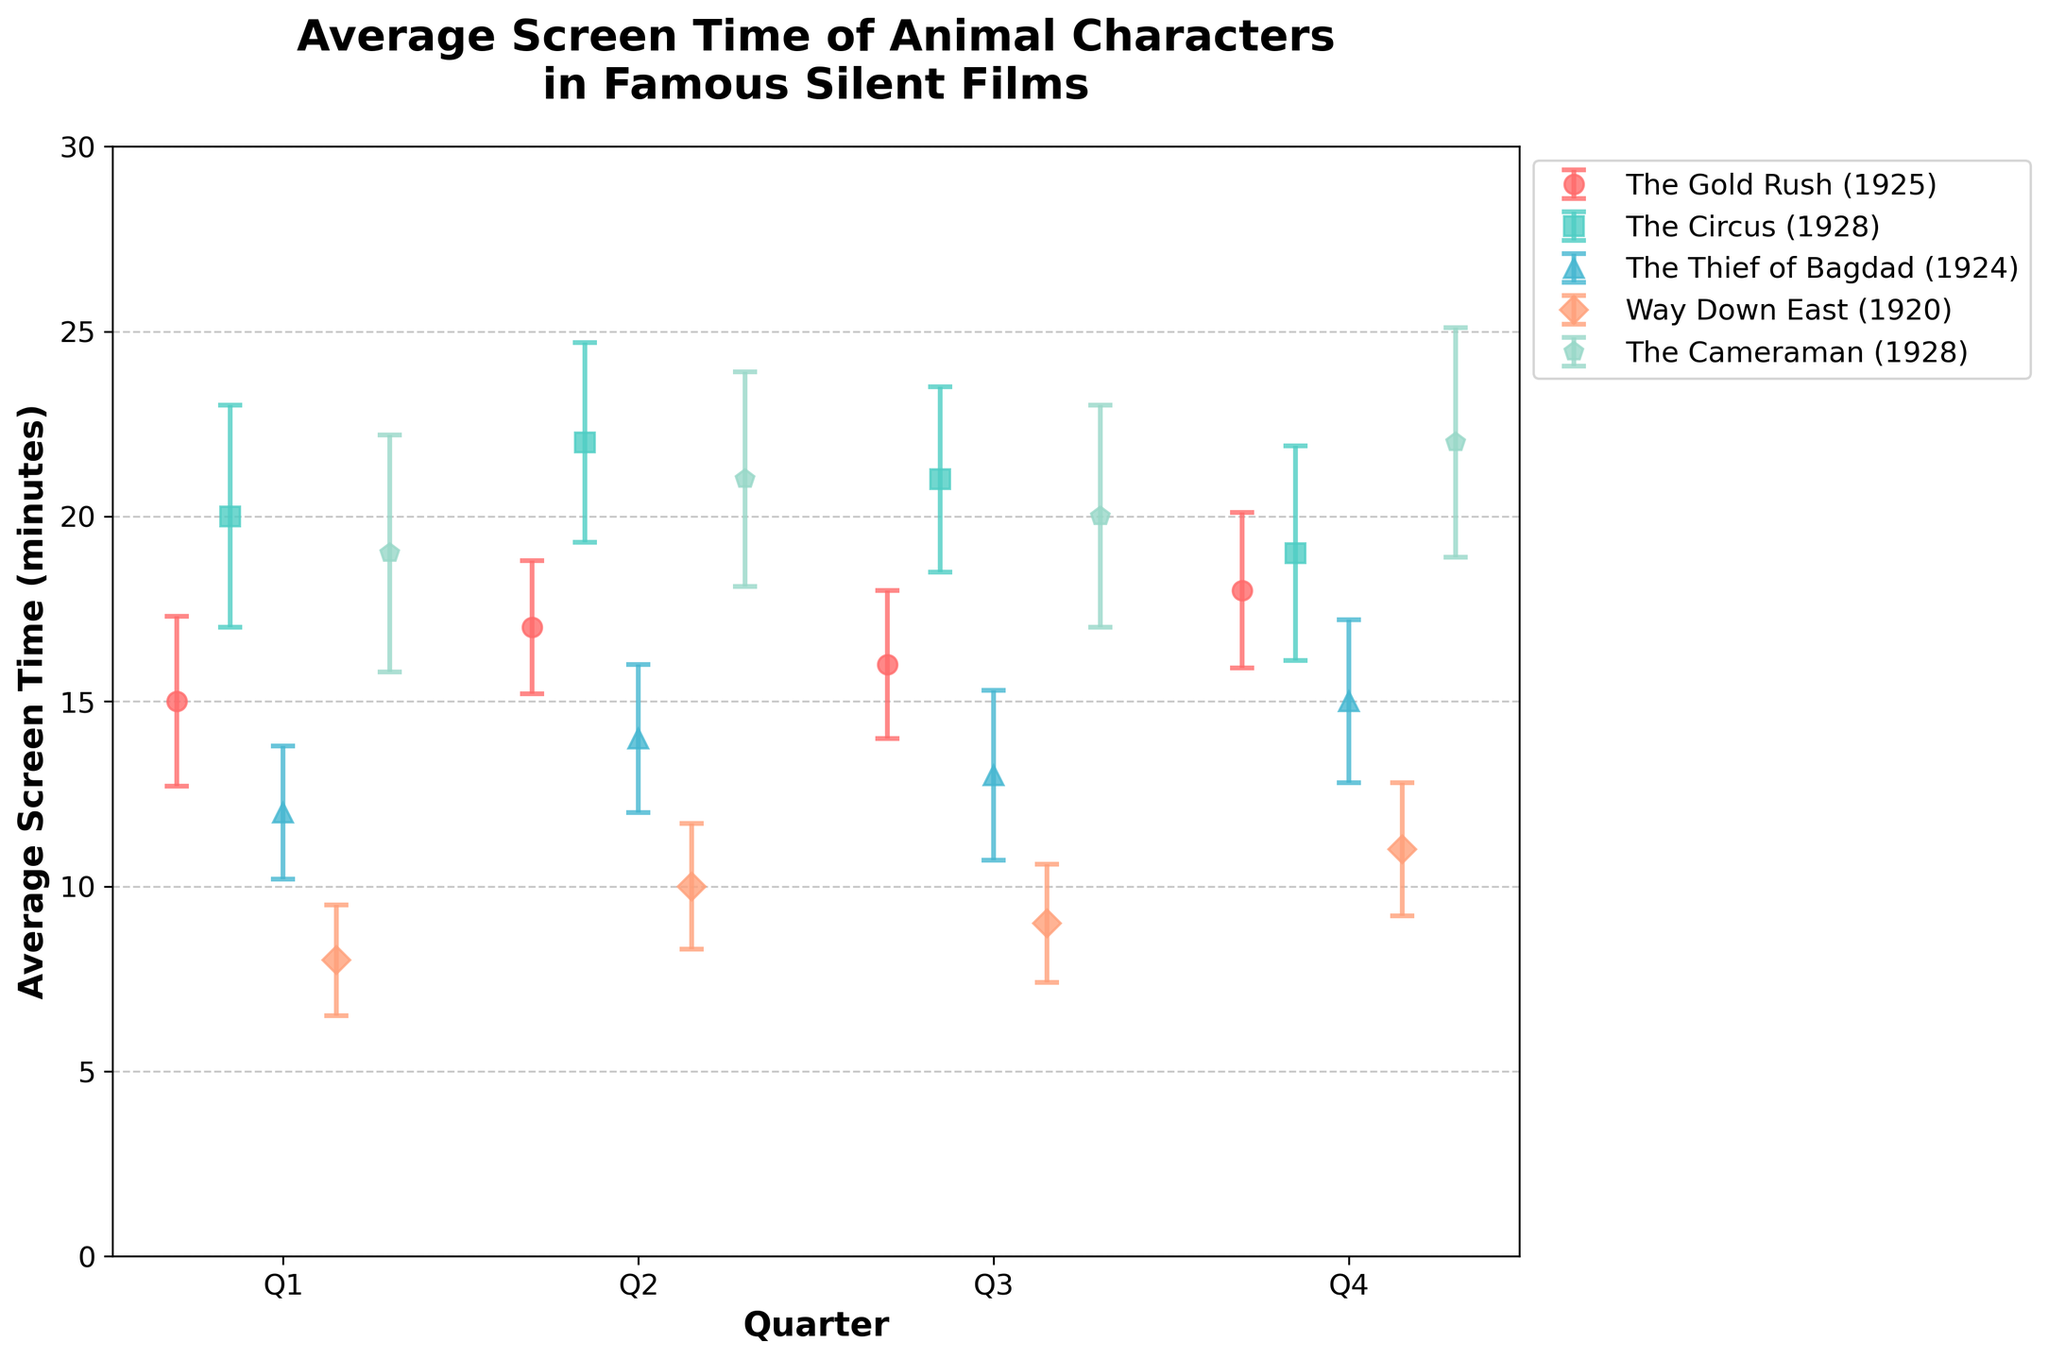What's the title of the figure? The titles of figures are typically found at the top and they are meant to describe the content of the figure concisely. The title of this figure is "Average Screen Time of Animal Characters in Famous Silent Films" along with a subtitle indicating quarterly variations.
Answer: Average Screen Time of Animal Characters in Famous Silent Films Which film has the highest average screen time for Q1? To find the film with the highest average screen time for Q1, locate the markers on the plot that correspond to Q1 and identify the one with the greatest height. "The Circus (1928)" has the highest marker in Q1.
Answer: "The Circus (1928)" What is the average screen time and the standard deviation for "The Thief of Bagdad (1924)" in Q3? Find the data points for "The Thief of Bagdad (1924)" and look specifically at Q3. The marker tells us the average screen time and the error bars indicate the standard deviation. The average is 13 minutes and the standard deviation is 2.3 minutes.
Answer: 13 minutes, 2.3 minutes Which quarter shows the greatest variation in screen time for "Way Down East (1920)"? To determine the quarter with the greatest variation, compare the lengths of the error bars (standard deviations) for each quarter in "Way Down East (1920)". Quarter 4 (Q4) has the longest error bar.
Answer: Q4 How does the average screen time of animal characters in "The Cameraman (1928)" change from Q1 to Q4? Track the changes in the vertical positions of the error bars for "The Cameraman (1928)" from Q1 to Q4. The average screen time increases from Q1 to Q4 (19 to 22 minutes).
Answer: Increases Which film has the smallest variability in screen time in Q2? To find out which film has the smallest variability, compare the lengths of the error bars (standard deviations) for Q2. "The Gold Rush (1925)" has the shortest error bar in Q2 with a standard deviation of 1.8 minutes.
Answer: "The Gold Rush (1925)" What is the difference in average screen time between Q4 and Q1 for "The Gold Rush (1925)"? Calculate the difference between the average screen times for Q4 and Q1 for "The Gold Rush (1925)". For Q4, the average screen time is 18 minutes and for Q1, it is 15 minutes. The difference is 18 - 15 = 3 minutes.
Answer: 3 minutes Which film shows a decrease in average screen time between Q2 and Q4? Look at the trend in average screen time for each film from Q2 to Q4. "The Circus (1928)" shows a decrease from 22 minutes in Q2 to 19 minutes in Q4.
Answer: "The Circus (1928)" What is the range of average screen time for "The Cameraman (1928)" across all quarters? Identify the minimum and maximum average screen times for "The Cameraman (1928)" across all quarters. The minimum is 19 minutes (Q1) and the maximum is 22 minutes (Q4). The range is 22 - 19 = 3 minutes.
Answer: 3 minutes Which film has the most consistent screen time across the quarters? Consistency can be determined by observing the error bars for each film. "Way Down East (1920)" shows relatively equal and small error bars across all quarters, indicating consistent screen time.
Answer: "Way Down East (1920)" 